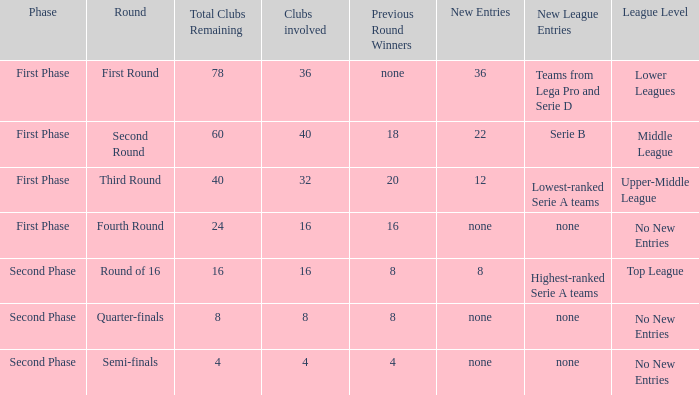In the third round, referred to as the round name, what new additions can be expected? 12.0. 